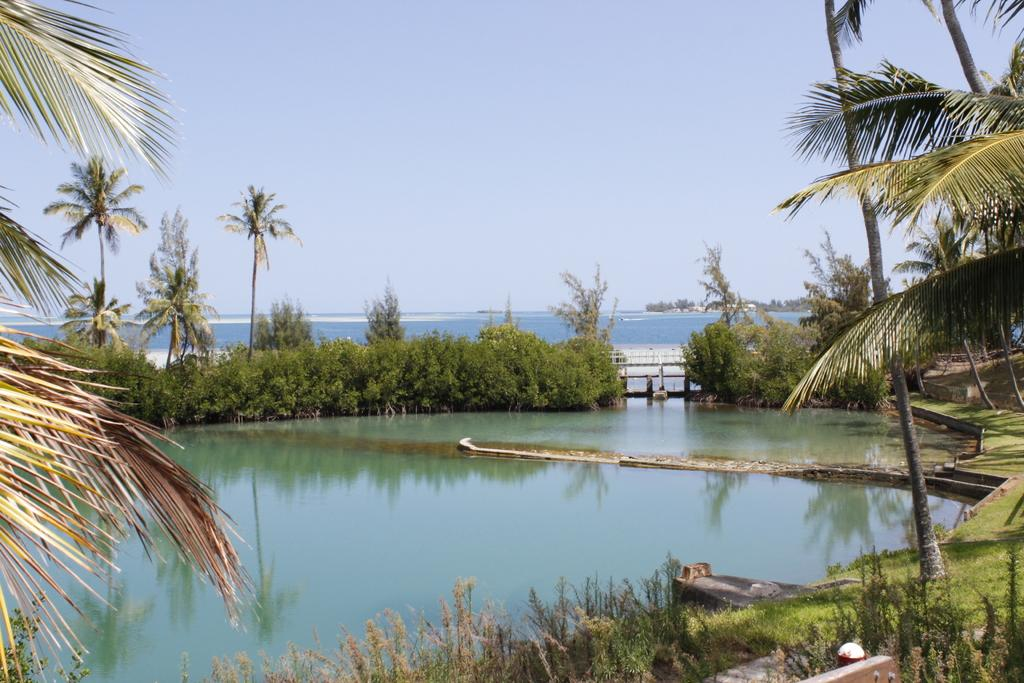What type of vegetation is at the bottom of the image? There are plants at the bottom of the image. What can be seen between the plants and the sky in the image? The surface of water is visible in the image. What type of tall vegetation is in the middle of the image? There are trees in the middle of the image. What is visible in the background of the image? The sky is visible in the background of the image. What type of lunch is being prepared in the image? There is no indication of lunch preparation in the image; it primarily features plants, water, trees, and the sky. How does the daughter interact with the plants in the image? There is no daughter present in the image, so it is not possible to describe any interactions with the plants. 